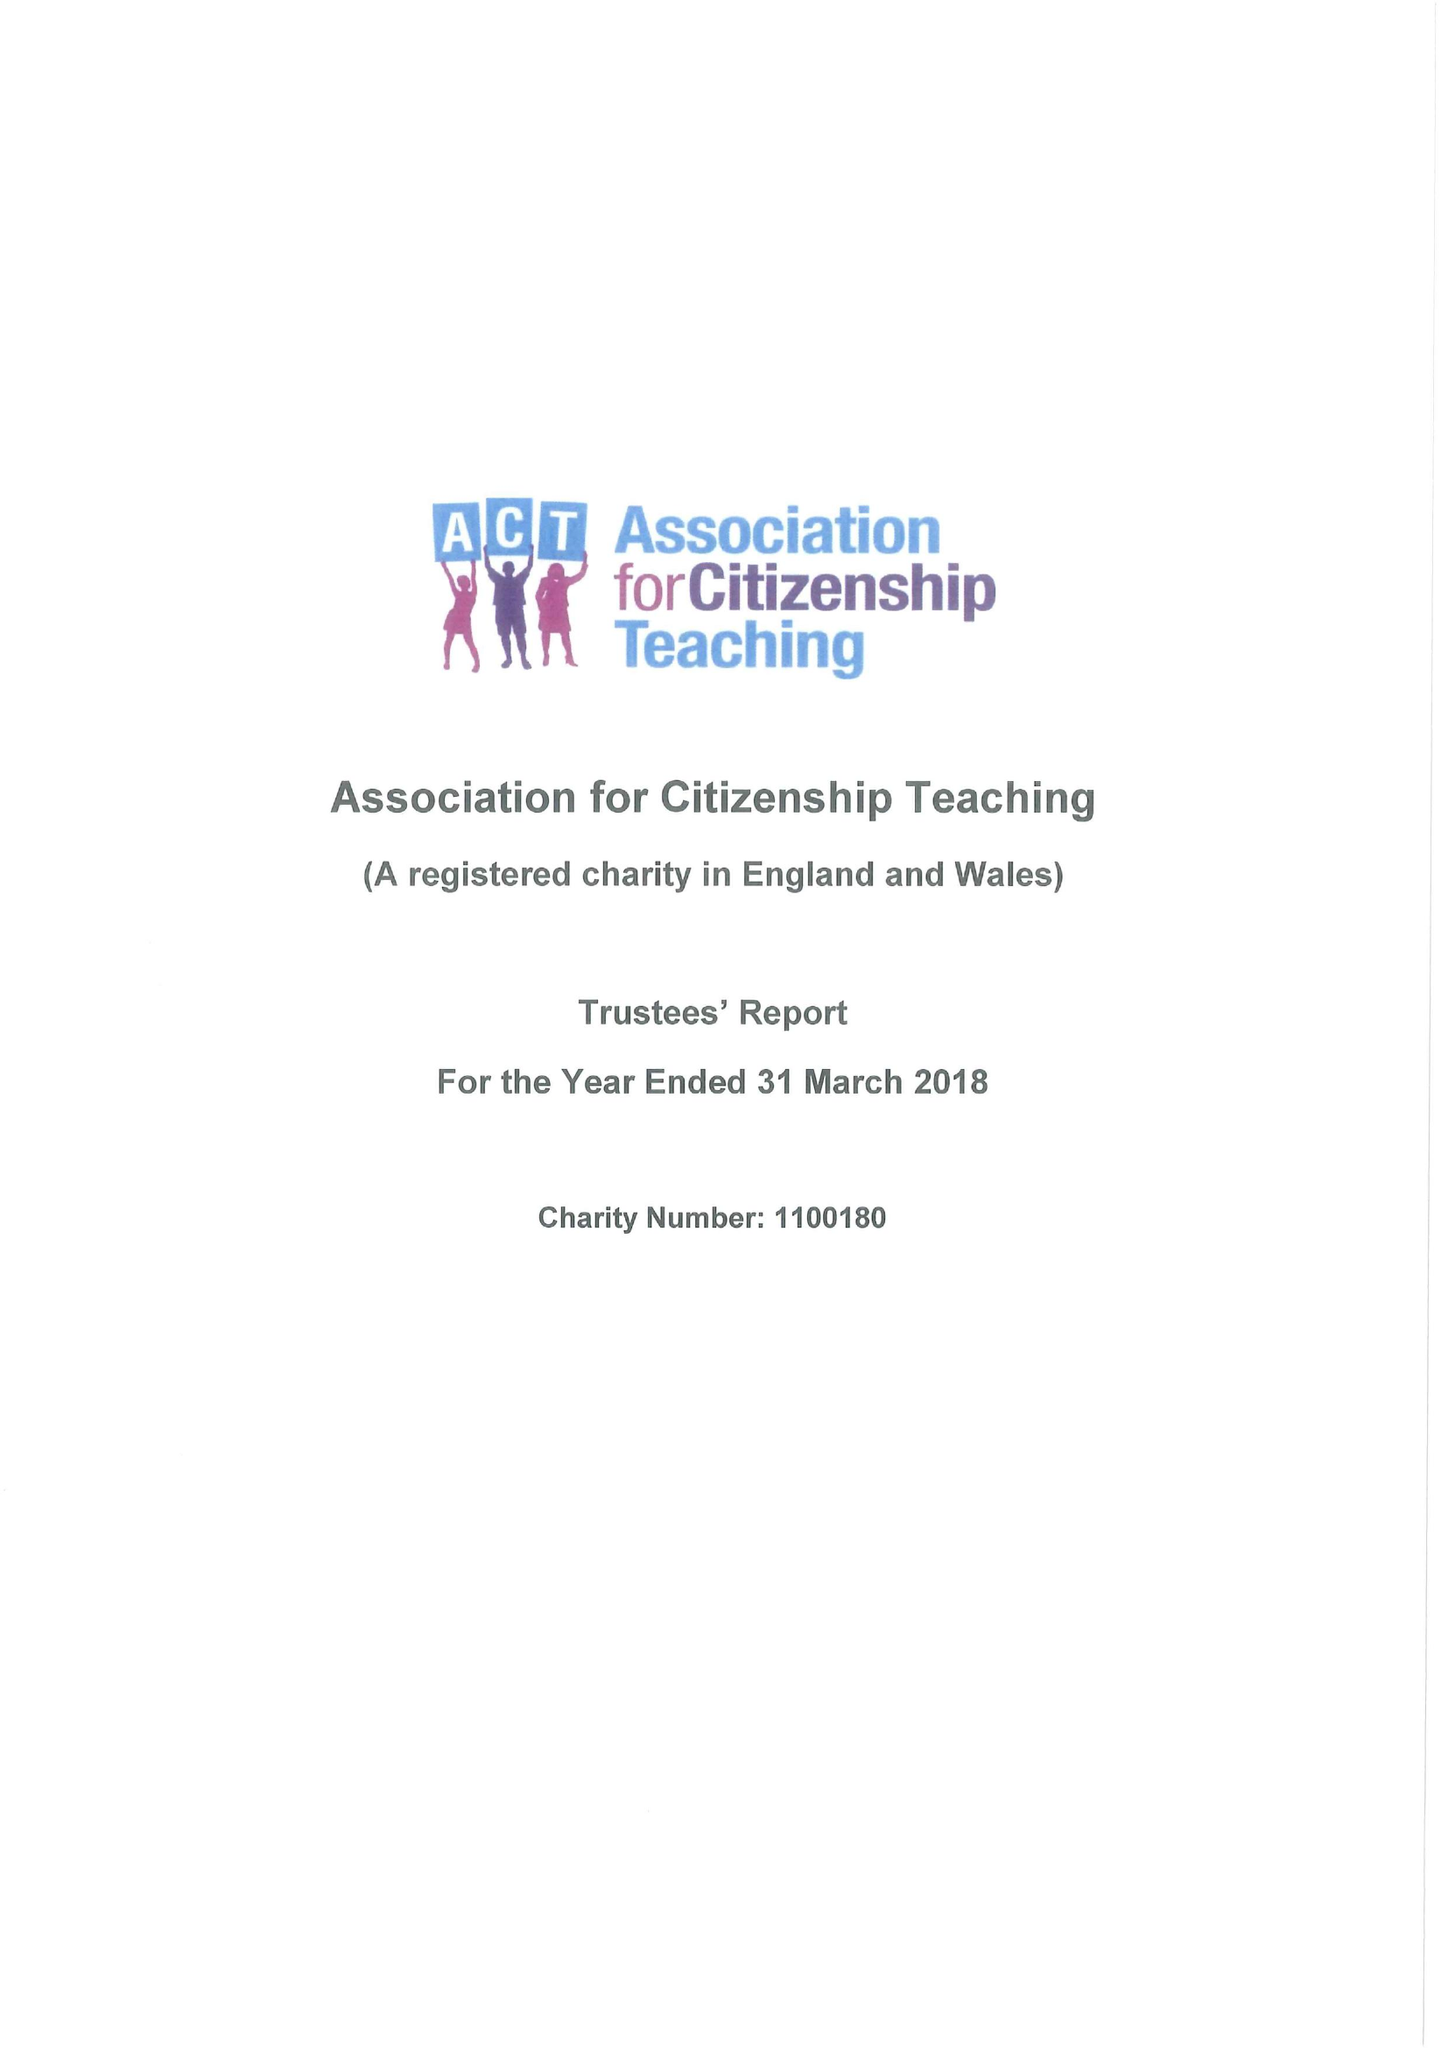What is the value for the charity_name?
Answer the question using a single word or phrase. Association For Citizenship Teaching 